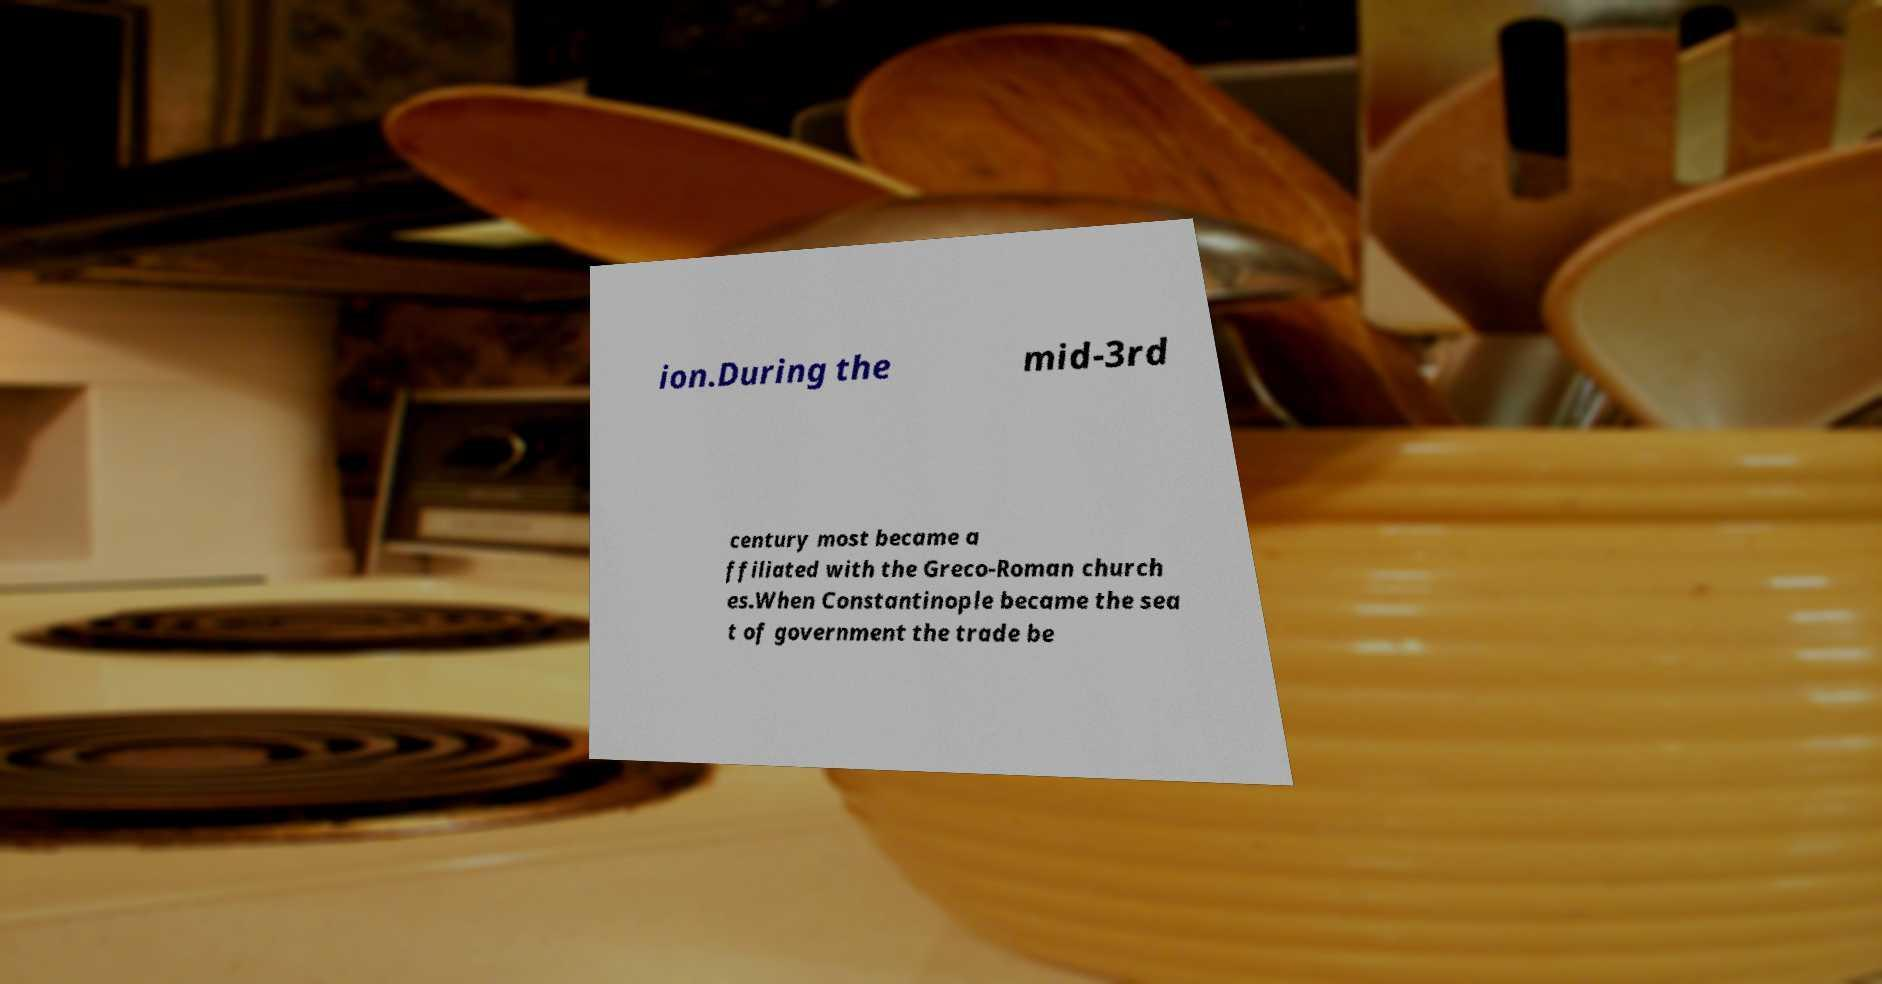There's text embedded in this image that I need extracted. Can you transcribe it verbatim? ion.During the mid-3rd century most became a ffiliated with the Greco-Roman church es.When Constantinople became the sea t of government the trade be 